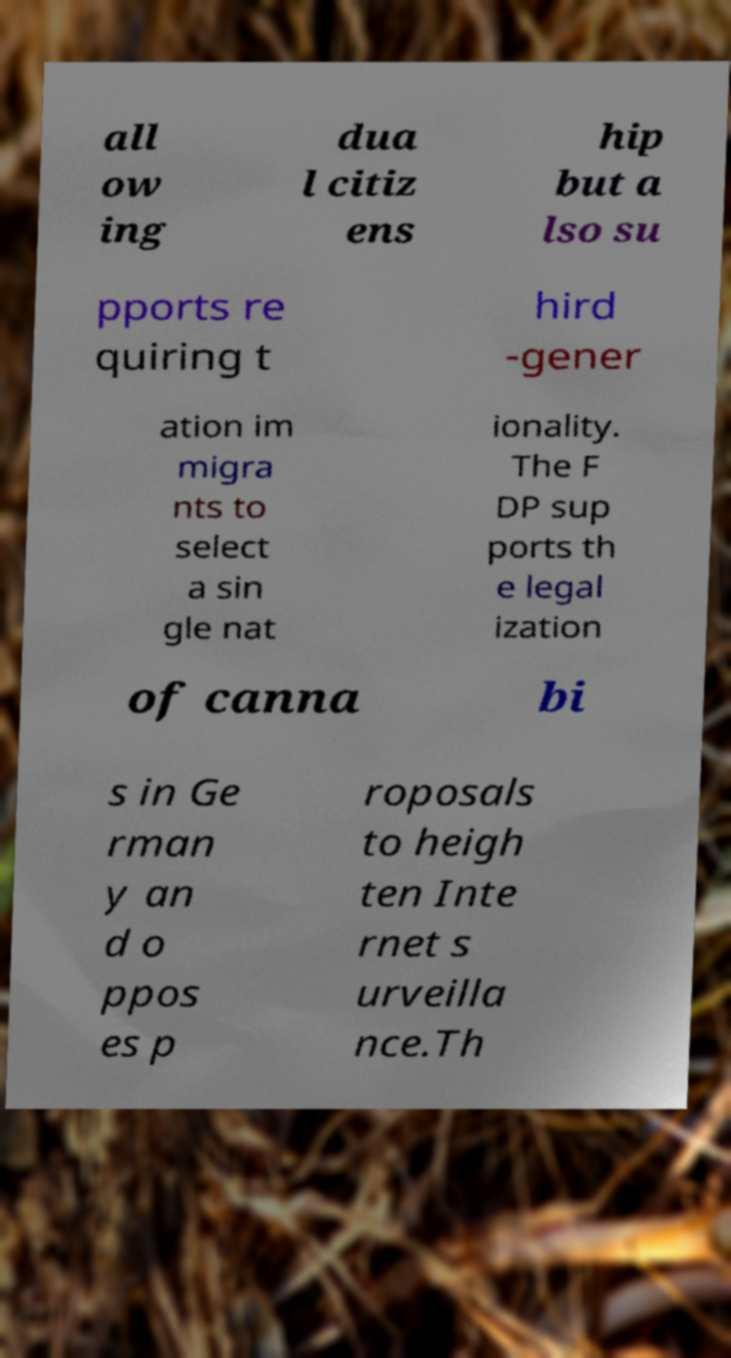There's text embedded in this image that I need extracted. Can you transcribe it verbatim? all ow ing dua l citiz ens hip but a lso su pports re quiring t hird -gener ation im migra nts to select a sin gle nat ionality. The F DP sup ports th e legal ization of canna bi s in Ge rman y an d o ppos es p roposals to heigh ten Inte rnet s urveilla nce.Th 